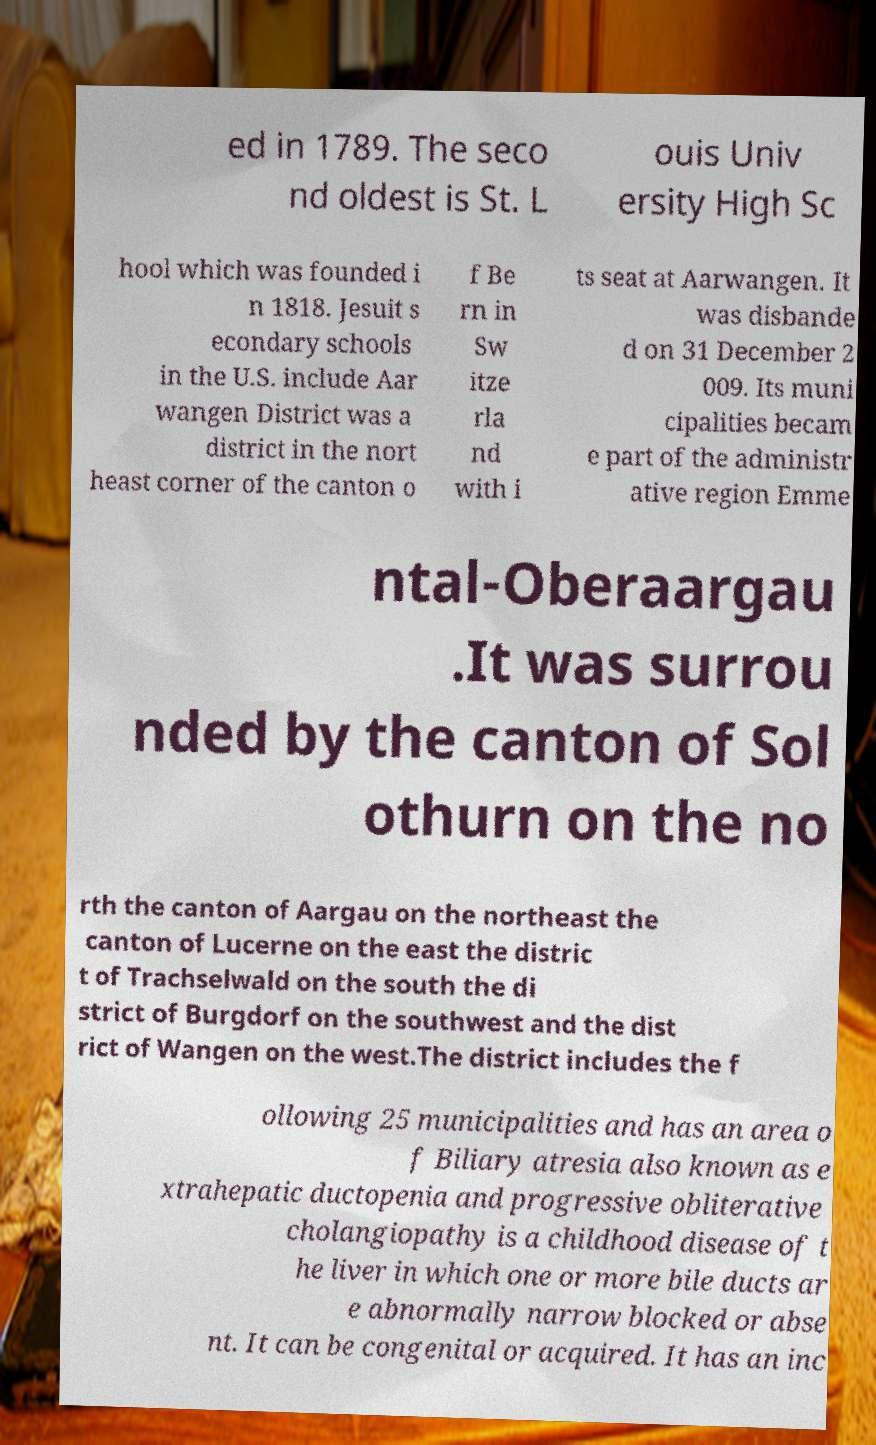Please identify and transcribe the text found in this image. ed in 1789. The seco nd oldest is St. L ouis Univ ersity High Sc hool which was founded i n 1818. Jesuit s econdary schools in the U.S. include Aar wangen District was a district in the nort heast corner of the canton o f Be rn in Sw itze rla nd with i ts seat at Aarwangen. It was disbande d on 31 December 2 009. Its muni cipalities becam e part of the administr ative region Emme ntal-Oberaargau .It was surrou nded by the canton of Sol othurn on the no rth the canton of Aargau on the northeast the canton of Lucerne on the east the distric t of Trachselwald on the south the di strict of Burgdorf on the southwest and the dist rict of Wangen on the west.The district includes the f ollowing 25 municipalities and has an area o f Biliary atresia also known as e xtrahepatic ductopenia and progressive obliterative cholangiopathy is a childhood disease of t he liver in which one or more bile ducts ar e abnormally narrow blocked or abse nt. It can be congenital or acquired. It has an inc 